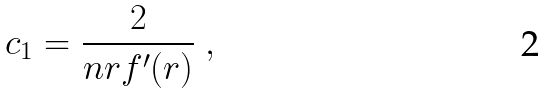<formula> <loc_0><loc_0><loc_500><loc_500>c _ { 1 } = \frac { 2 } { n r f ^ { \prime } ( r ) } \ ,</formula> 